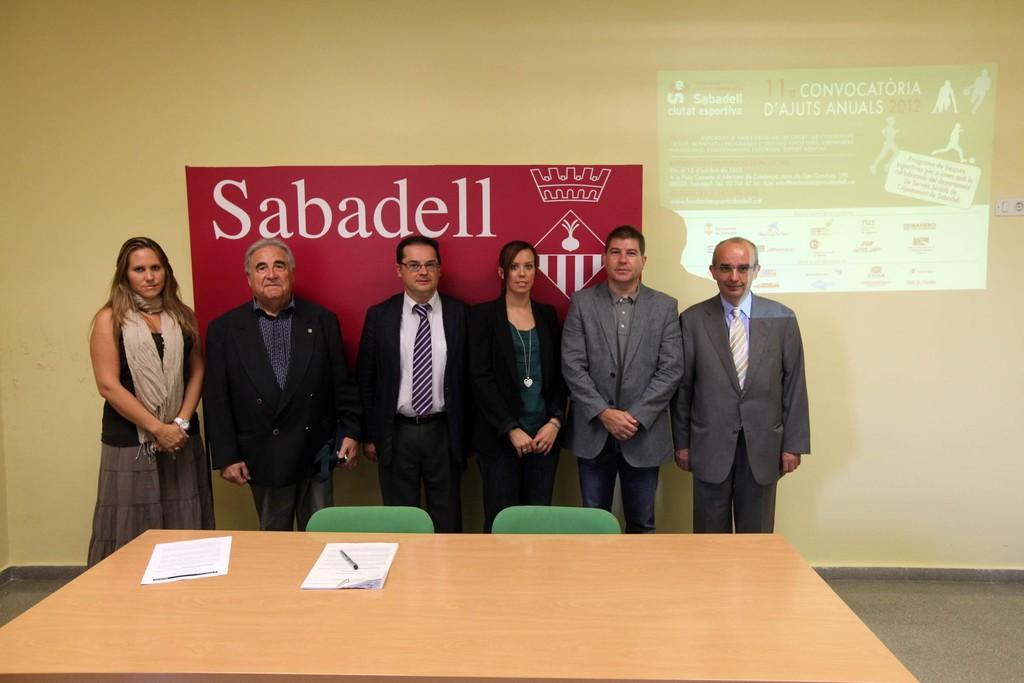How many people are in the image? There is a group of people standing in the image. Where are the people standing? The people are standing on the floor. What is on the table in the image? Papers are present on the table. What type of furniture is visible in the image? There are chairs in the image. What is visible in the background of the image? There is a wall visible in the image. What type of cracker is being used as a prop in the image? There is no cracker present in the image. Can you describe the running style of the people in the image? The people in the image are not running; they are standing still. 